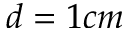Convert formula to latex. <formula><loc_0><loc_0><loc_500><loc_500>d = 1 c m</formula> 